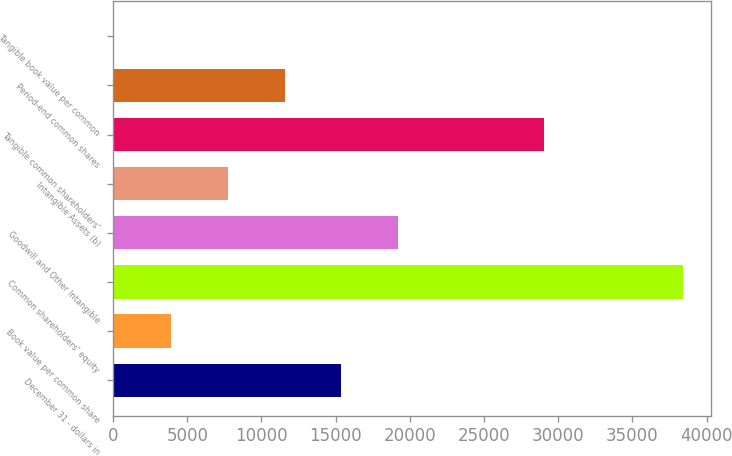<chart> <loc_0><loc_0><loc_500><loc_500><bar_chart><fcel>December 31 - dollars in<fcel>Book value per common share<fcel>Common shareholders' equity<fcel>Goodwill and Other Intangible<fcel>Intangible Assets (b)<fcel>Tangible common shareholders'<fcel>Period-end common shares<fcel>Tangible book value per common<nl><fcel>15389.5<fcel>3888.31<fcel>38392<fcel>19223.3<fcel>7722.05<fcel>29071<fcel>11555.8<fcel>54.57<nl></chart> 